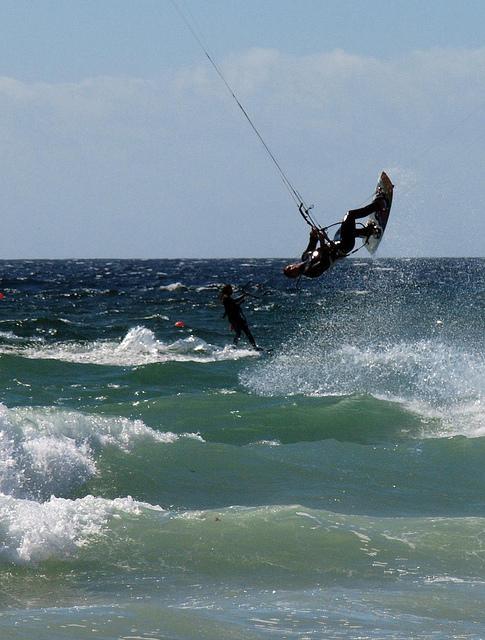Is there lots of water or mainly land in the picture?
Quick response, please. Water. Is the water cold?
Short answer required. Yes. Is this a female or male?
Answer briefly. Male. 